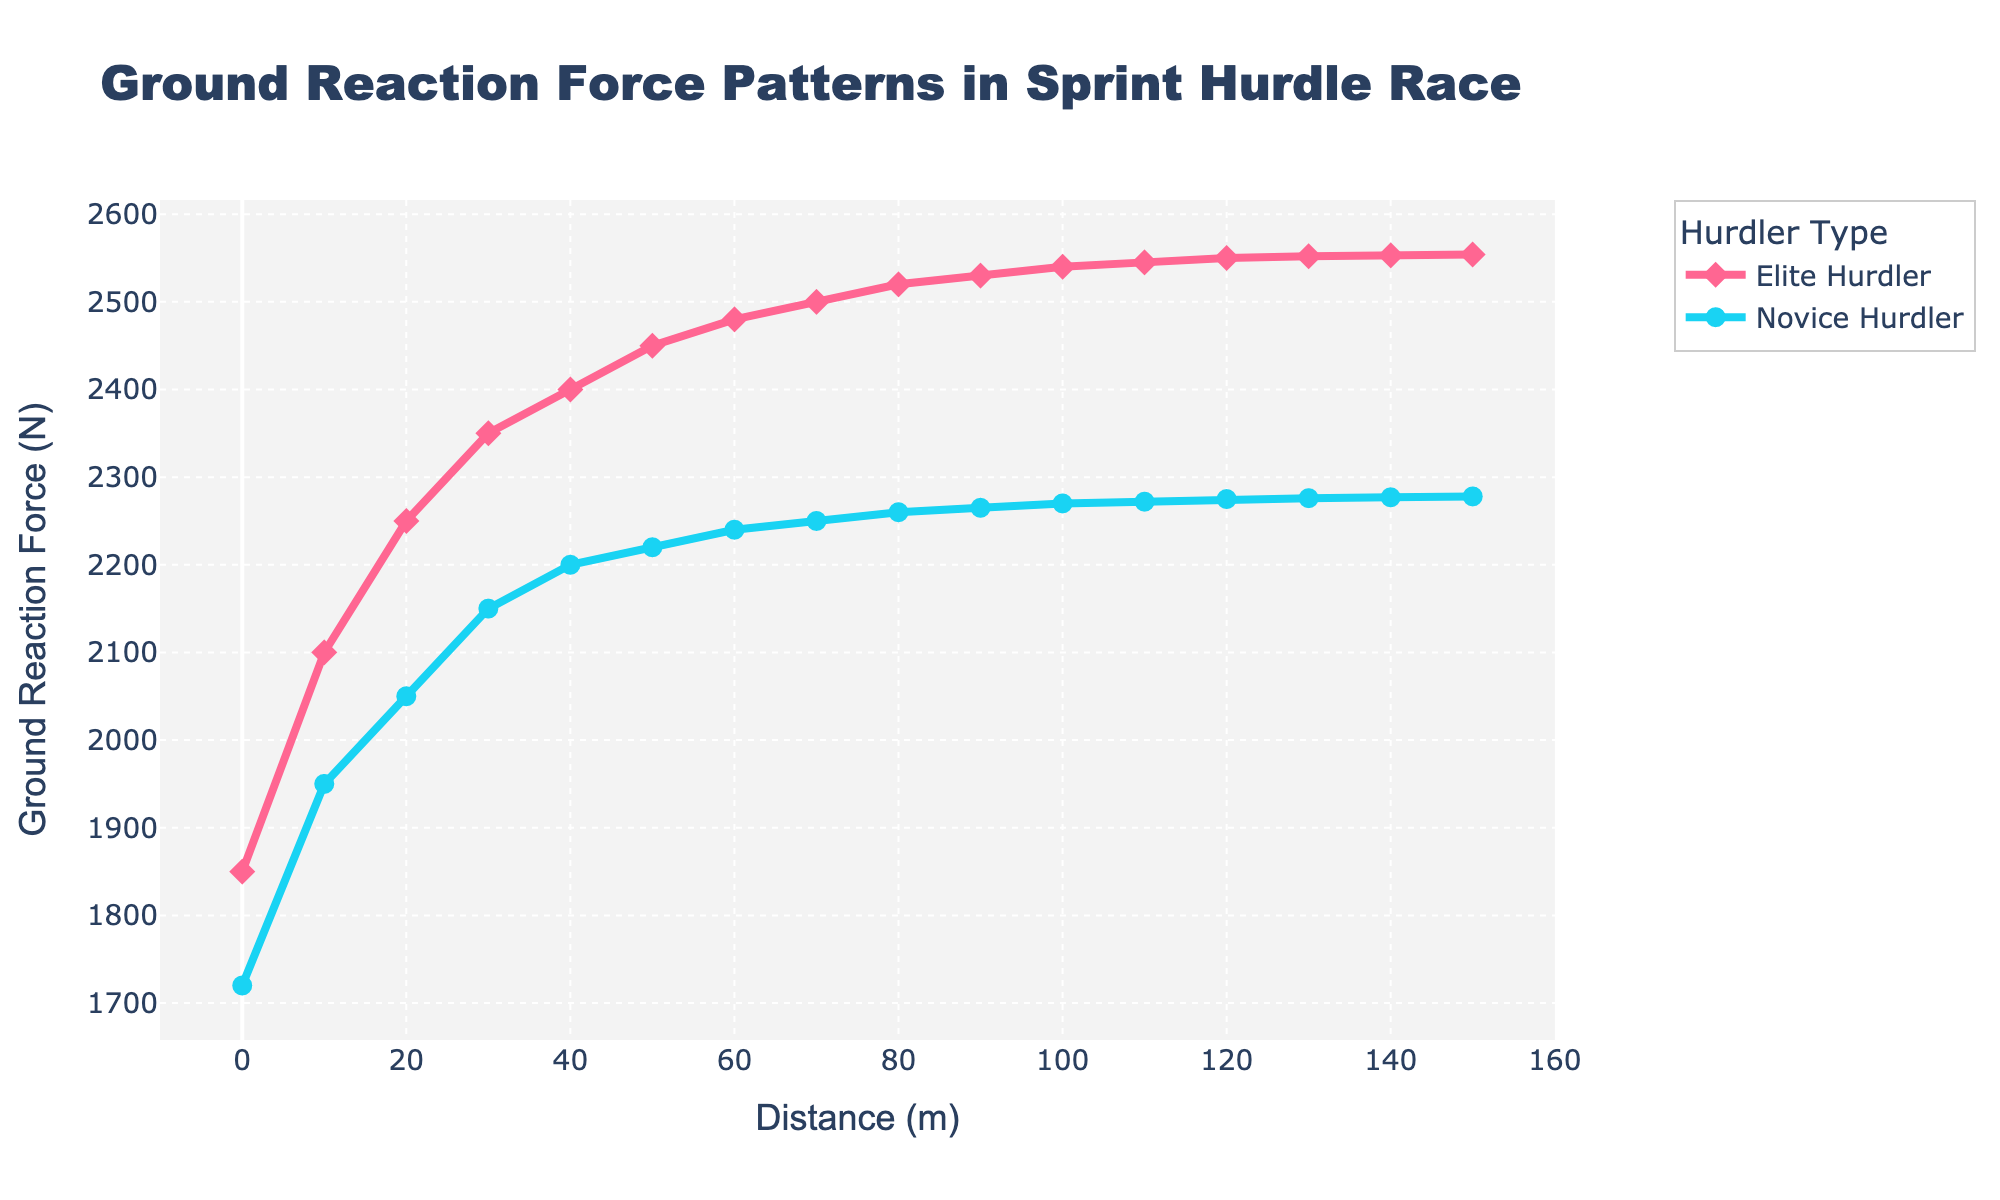Which hurdler has the higher ground reaction force (GRF) at 50 meters? At 50 meters, look at the two points for Elite and Novice hurdlers and compare their GRFs. The Elite Hurdler has a GRF of 2450 N, while the Novice Hurdler has 2220 N. Therefore, the Elite Hurdler has the higher GRF.
Answer: Elite Hurdler What is the difference in GRF between the Elite and Novice hurdlers at 90 meters? At 90 meters, the Elite Hurdler has a GRF of 2530 N, and the Novice Hurdler has a GRF of 2265 N. The difference is 2530 - 2265 = 265 N.
Answer: 265 N Which hurdler shows a more rapid increase in GRF between the starting point (0 meters) and 40 meters? Compare the GRF values for both hurdlers at 0 meters and 40 meters. For the Elite Hurdler, the increase is from 1850 N to 2400 N (2400 - 1850 = 550 N). For the Novice Hurdler, it is from 1720 N to 2200 N (2200 - 1720 = 480 N). The Elite Hurdler shows a more rapid increase.
Answer: Elite Hurdler At what distance does the GRF of the Elite Hurdler stabilize and no longer increase significantly? Observe the pattern of the Elite Hurdler's GRF throughout the distance. The GRF stabilizes around 130-140 meters, as the values from 130 meters (2552 N) to 150 meters (2554 N) do not show significant increase.
Answer: 130-140 meters What is the average GRF of the Novice Hurdler at 0, 50, and 100 meters? Find the GRF values for the Novice Hurdler at 0 meters (1720 N), 50 meters (2220 N), and 100 meters (2270 N). Calculate the average: (1720 + 2220 + 2270) / 3 = 6210 / 3 = 2070 N.
Answer: 2070 N Which color represents Elite Hurdlers in the plot? Examine the visual attributes of the plot. The line representing the Elite Hurdler is pink with diamond symbols.
Answer: Pink What is the total GRF increase for the Novice Hurdler from 0 to 150 meters? Calculate the Novice Hurdler's GRF at 0 meters (1720 N) and 150 meters (2278 N). The increase is 2278 - 1720 = 558 N.
Answer: 558 N How much higher is the GRF of the Elite Hurdler compared to the Novice Hurdler at their peak values? The peak GRF for the Elite Hurdler is 2554 N at around 150 meters, and for the Novice Hurdler it is 2278 N. The difference is 2554 - 2278 = 276 N.
Answer: 276 N 